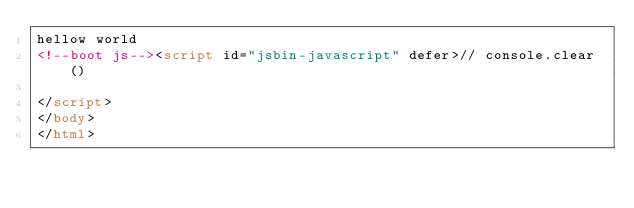Convert code to text. <code><loc_0><loc_0><loc_500><loc_500><_HTML_>hellow world
<!--boot js--><script id="jsbin-javascript" defer>// console.clear()

</script>
</body>
</html></code> 